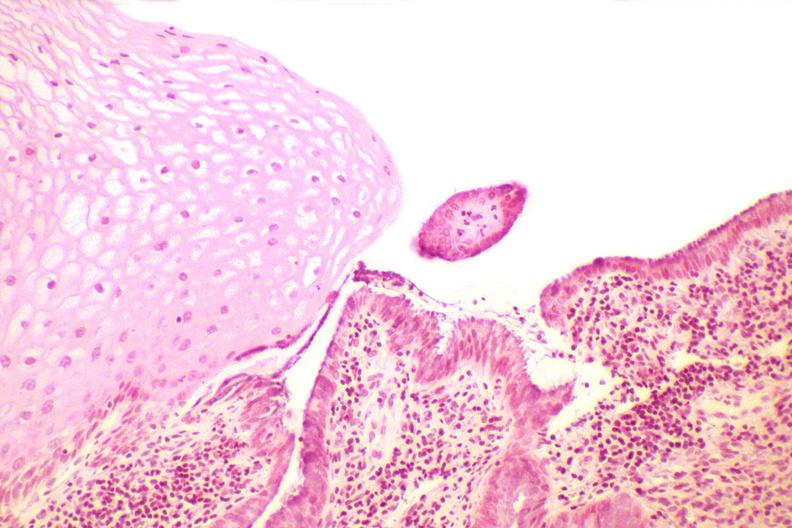does conjoined twins show cervix, squamocolumnar junction?
Answer the question using a single word or phrase. No 